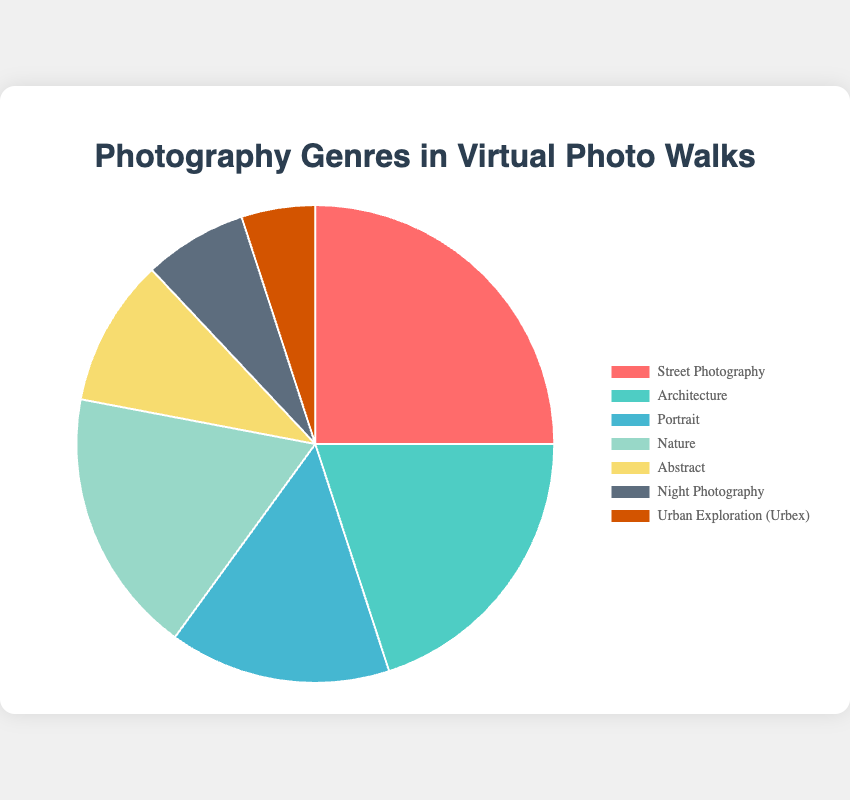What percentage of the photos taken were portraits? The pie chart directly tells us the percentage of photos taken in each genre. We need to find the 'Portrait' slice.
Answer: 15% How does the percentage of street photography compare to that of nature photography? The chart shows that street photography accounts for 25% and nature photography is at 18%. We subtract the two values to determine the difference.
Answer: 7% more street photography Which genre has the smallest representation in the virtual photo walks? By looking at the pie chart slices and their corresponding percentages, the smallest section represents Urban Exploration (Urbex) with 5%.
Answer: Urban Exploration (Urbex) What is the combined percentage of abstract and night photography photos? Adding the percentages of abstract (10%) and night photography (7%) gives us the combined percentage.
Answer: 17% What fraction of the photos taken are street photography and architecture combined? Adding the percentages of street photography (25%) and architecture (20%) gives us the combined percentage.
Answer: 45% Is the percentage of nature photos higher than that of portrait photos? By comparing the two percentages from the chart, nature is at 18% and portrait is at 15%. 18% is higher than 15%.
Answer: Yes Which genre is depicted by the largest slice of the pie chart? The largest slice on the pie chart represents the genre with the highest percentage which is street photography at 25%.
Answer: Street Photography Are there more photos of nature or architecture? From their respective percentages on the chart, nature is at 18% and architecture is at 20%.
Answer: Architecture How much more prominent is architecture photography compared to night photography? Subtract the percentage of night photography (7%) from architecture (20%).
Answer: 13% more If abstract and architectural photography combined form one genre, would it surpass the street photography genre? Adding abstract (10%) and architecture (20%) gives a total of 30%, which is higher than street photography's 25%.
Answer: Yes 